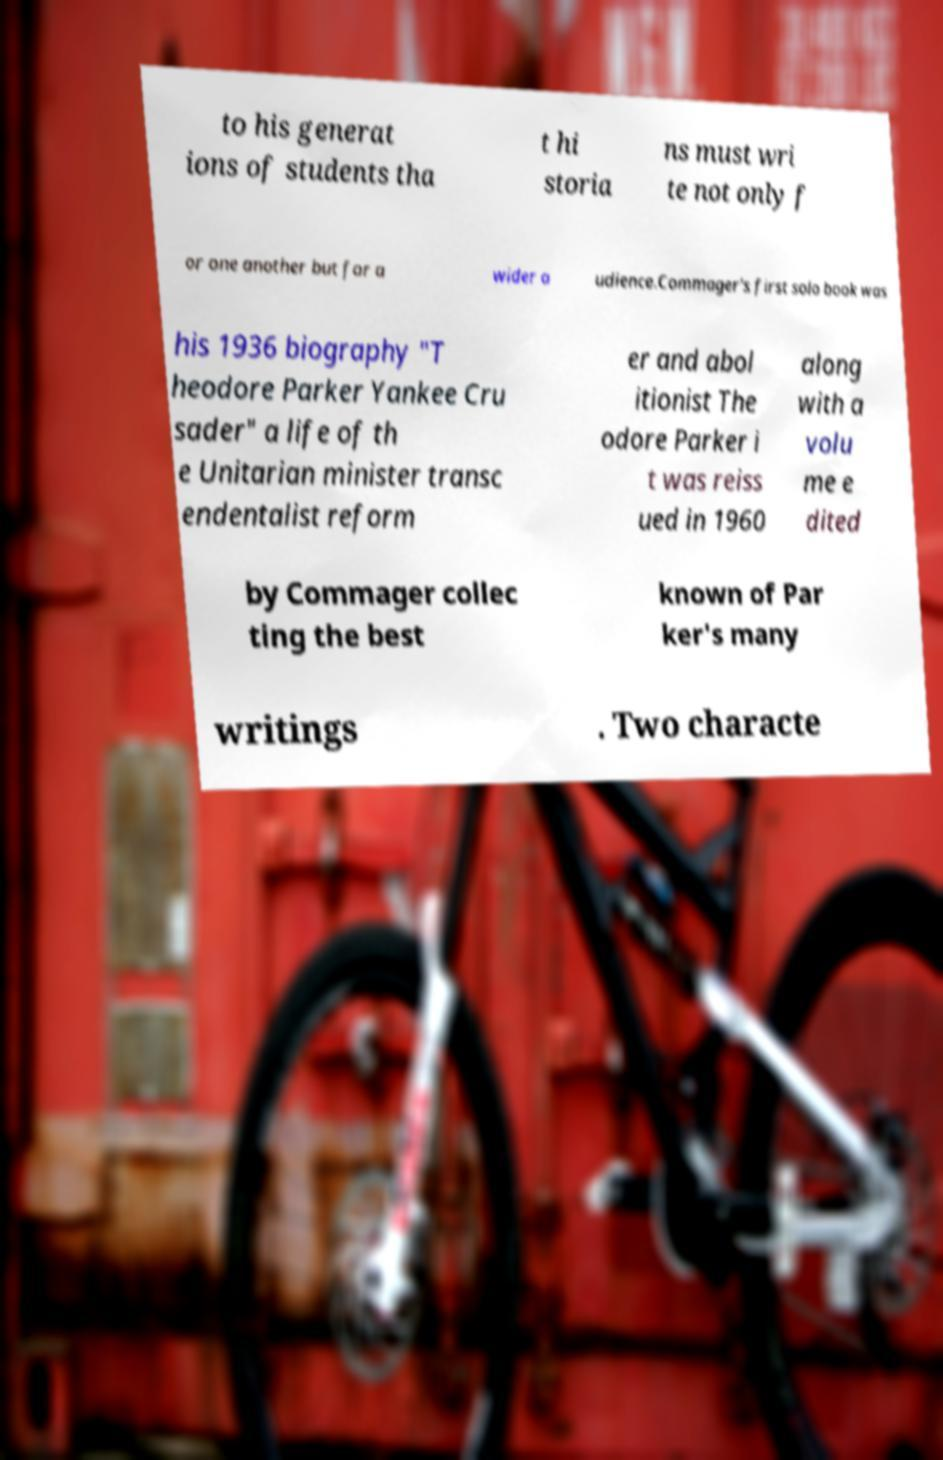Can you read and provide the text displayed in the image?This photo seems to have some interesting text. Can you extract and type it out for me? to his generat ions of students tha t hi storia ns must wri te not only f or one another but for a wider a udience.Commager's first solo book was his 1936 biography "T heodore Parker Yankee Cru sader" a life of th e Unitarian minister transc endentalist reform er and abol itionist The odore Parker i t was reiss ued in 1960 along with a volu me e dited by Commager collec ting the best known of Par ker's many writings . Two characte 